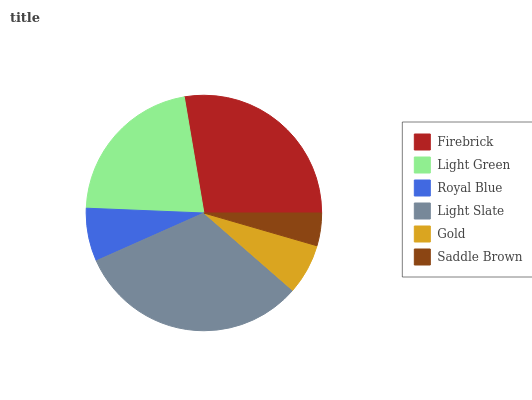Is Saddle Brown the minimum?
Answer yes or no. Yes. Is Light Slate the maximum?
Answer yes or no. Yes. Is Light Green the minimum?
Answer yes or no. No. Is Light Green the maximum?
Answer yes or no. No. Is Firebrick greater than Light Green?
Answer yes or no. Yes. Is Light Green less than Firebrick?
Answer yes or no. Yes. Is Light Green greater than Firebrick?
Answer yes or no. No. Is Firebrick less than Light Green?
Answer yes or no. No. Is Light Green the high median?
Answer yes or no. Yes. Is Royal Blue the low median?
Answer yes or no. Yes. Is Light Slate the high median?
Answer yes or no. No. Is Saddle Brown the low median?
Answer yes or no. No. 